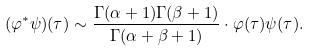Convert formula to latex. <formula><loc_0><loc_0><loc_500><loc_500>( \varphi ^ { * } \psi ) ( \tau ) \sim \frac { \Gamma ( \alpha + 1 ) \Gamma ( \beta + 1 ) } { \Gamma ( \alpha + \beta + 1 ) } \cdot \varphi ( \tau ) \psi ( \tau ) .</formula> 